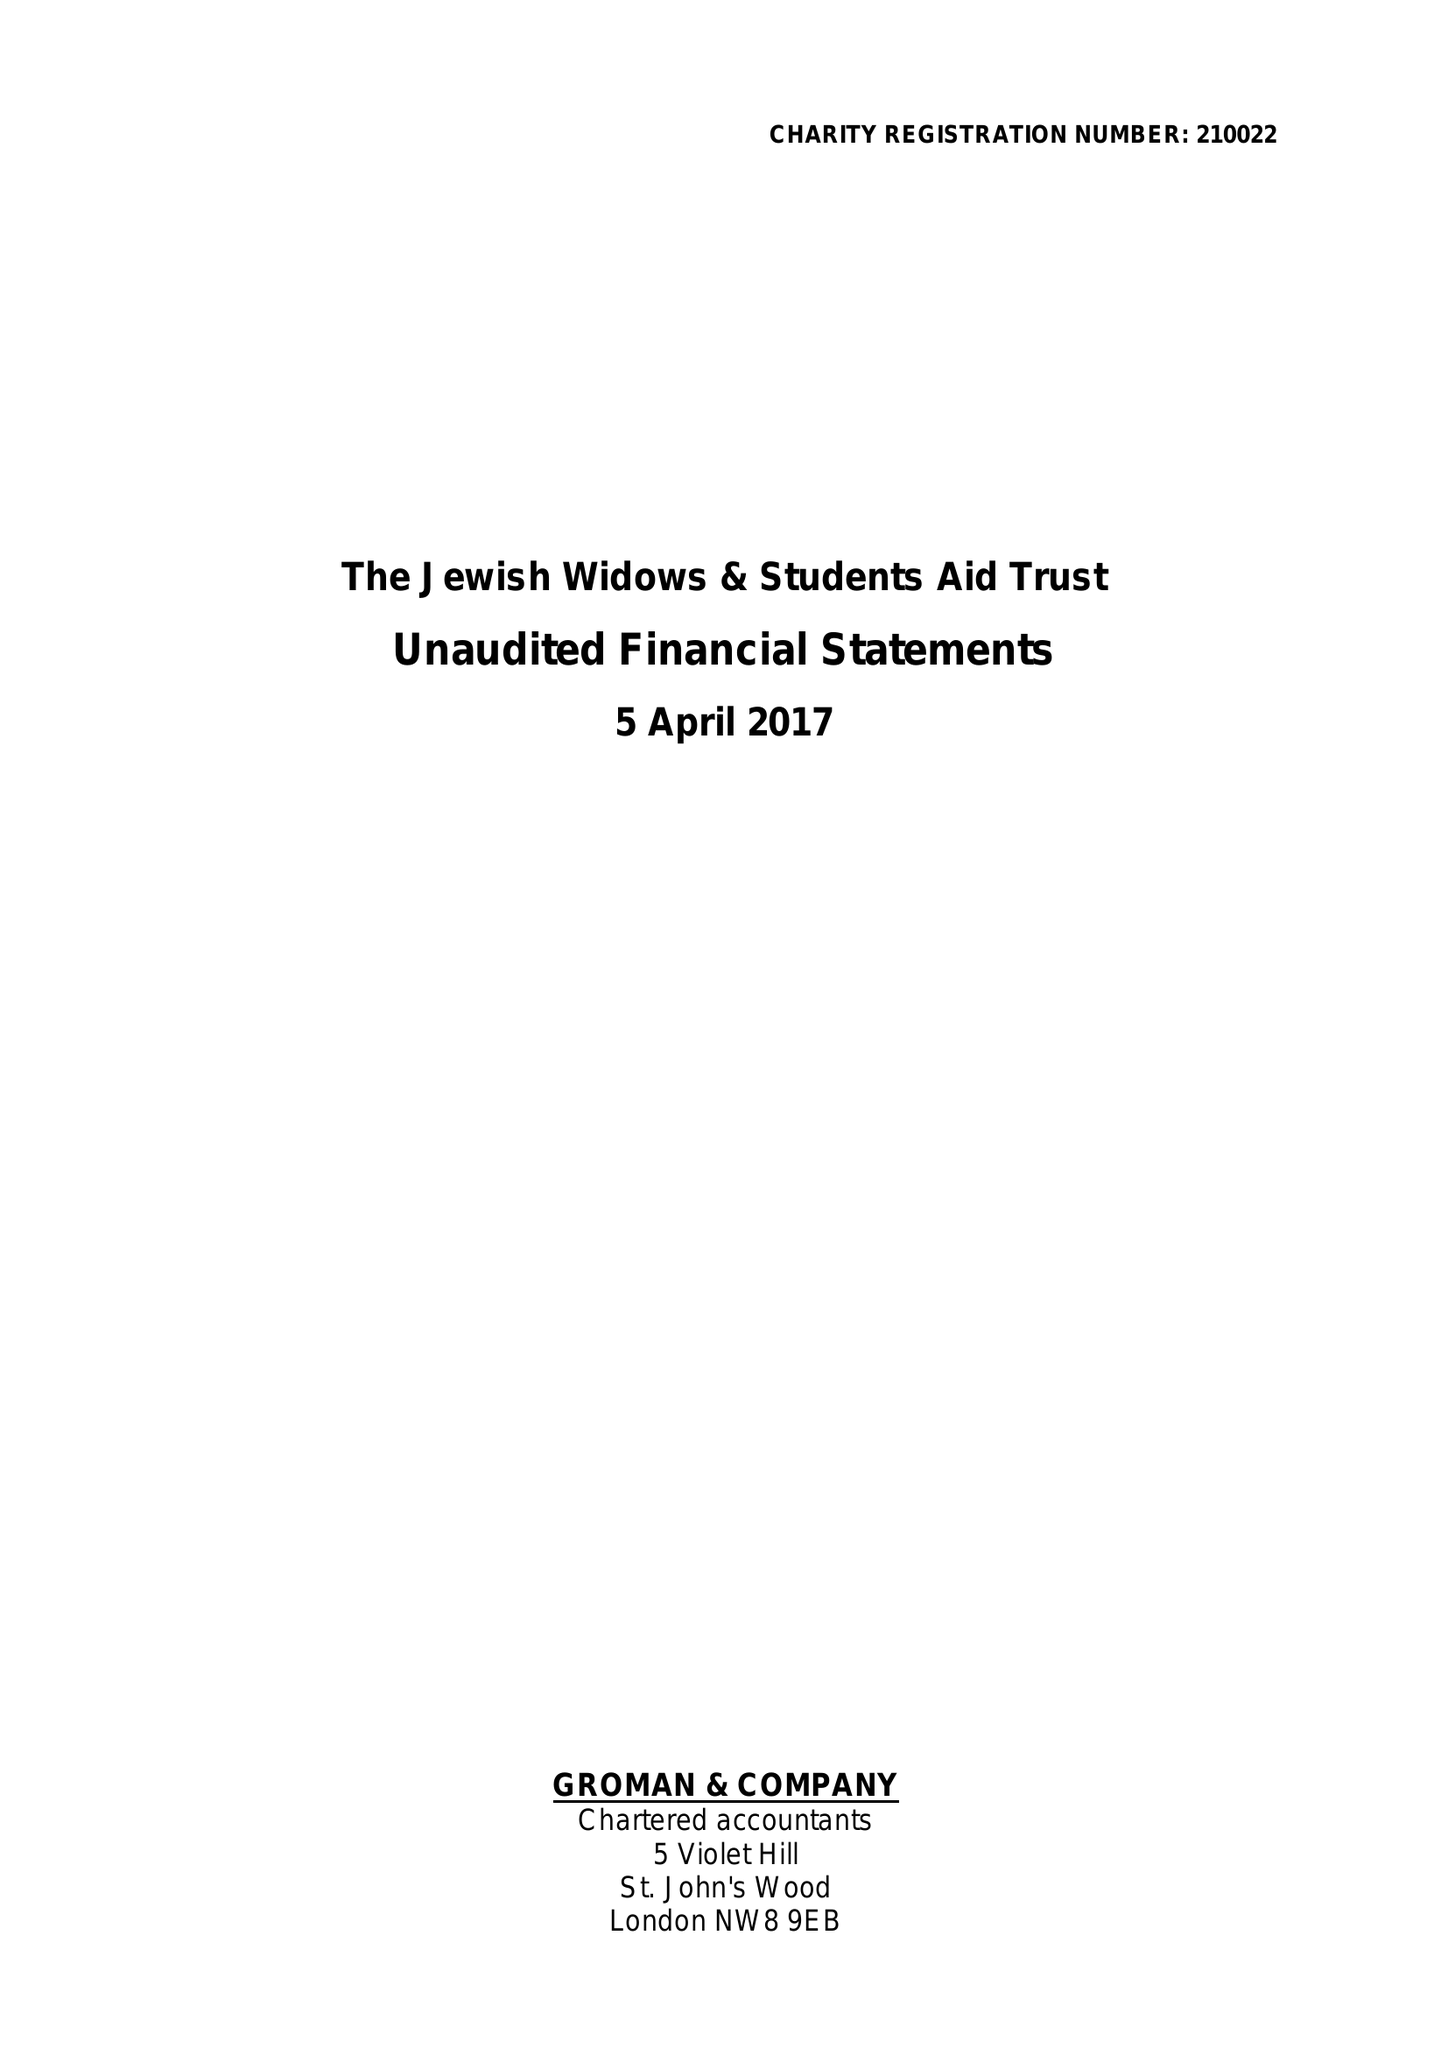What is the value for the charity_name?
Answer the question using a single word or phrase. The Jewish Widows and Students Aid Trust 